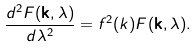<formula> <loc_0><loc_0><loc_500><loc_500>\frac { d ^ { 2 } F ( \mathbf k , \lambda ) } { d \lambda ^ { 2 } } = f ^ { 2 } ( k ) F ( \mathbf k , \lambda ) .</formula> 